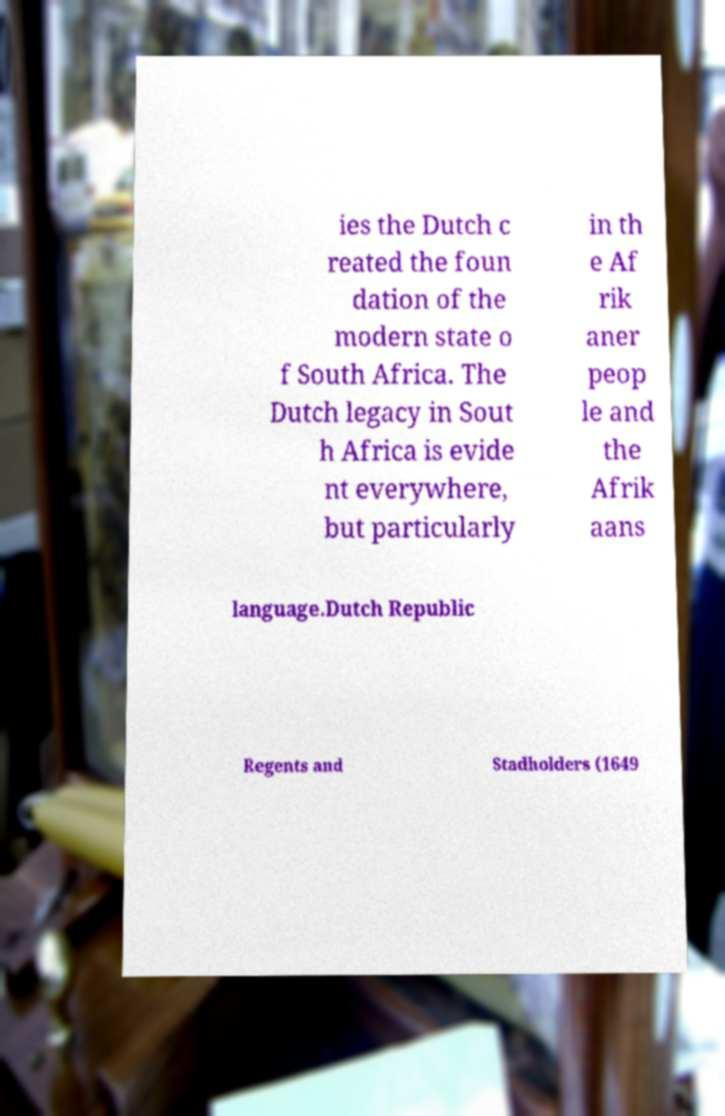Please identify and transcribe the text found in this image. ies the Dutch c reated the foun dation of the modern state o f South Africa. The Dutch legacy in Sout h Africa is evide nt everywhere, but particularly in th e Af rik aner peop le and the Afrik aans language.Dutch Republic Regents and Stadholders (1649 